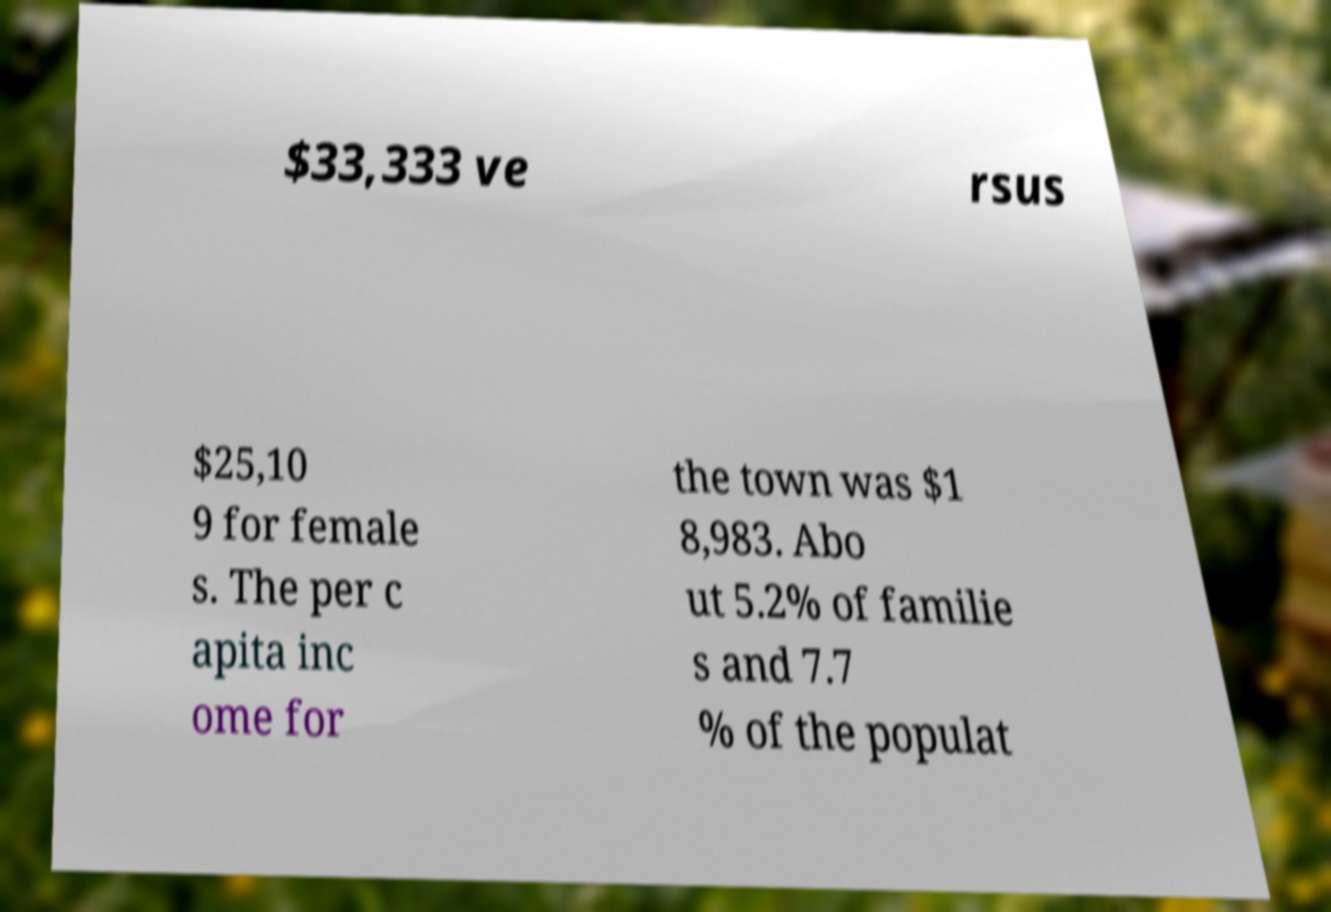Can you accurately transcribe the text from the provided image for me? $33,333 ve rsus $25,10 9 for female s. The per c apita inc ome for the town was $1 8,983. Abo ut 5.2% of familie s and 7.7 % of the populat 